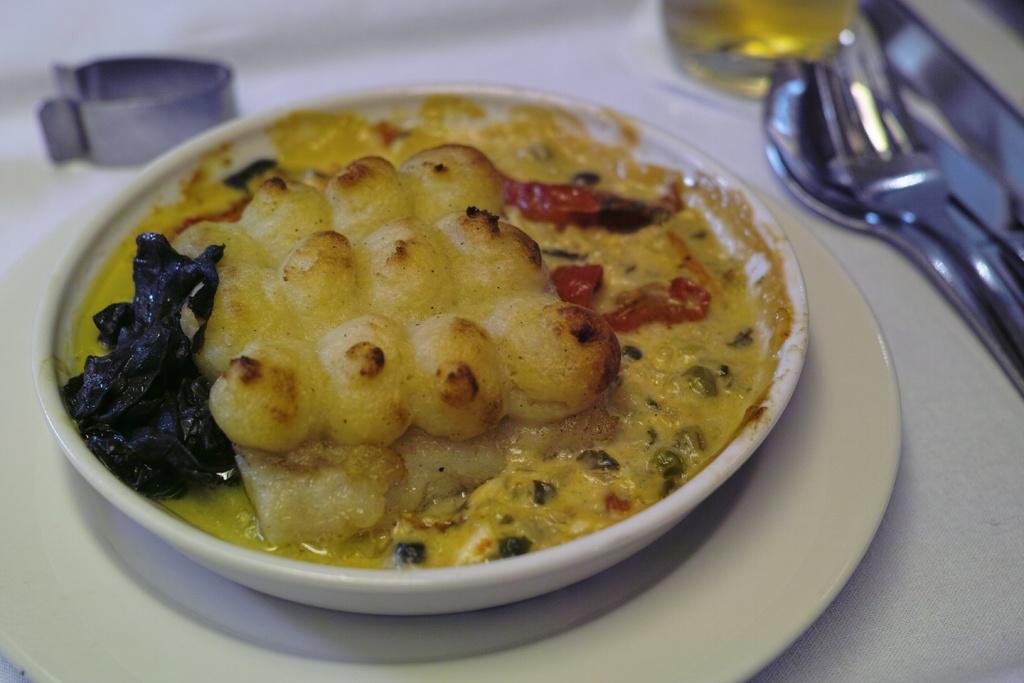Can you describe this image briefly? In the image there is a bowl with food item in it. Below the bowl there is a plate. And on the right side corner of the image there is a fork and a spoon. And there is a blur background. 